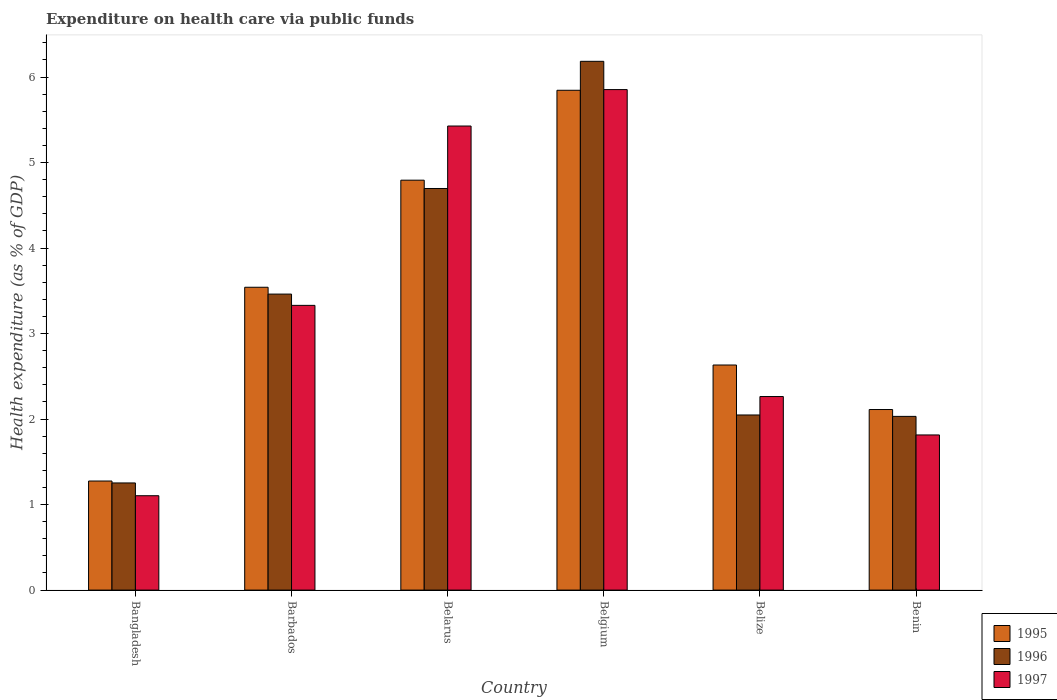How many groups of bars are there?
Keep it short and to the point. 6. How many bars are there on the 3rd tick from the right?
Give a very brief answer. 3. What is the label of the 2nd group of bars from the left?
Offer a very short reply. Barbados. What is the expenditure made on health care in 1995 in Bangladesh?
Give a very brief answer. 1.28. Across all countries, what is the maximum expenditure made on health care in 1996?
Ensure brevity in your answer.  6.18. Across all countries, what is the minimum expenditure made on health care in 1996?
Provide a short and direct response. 1.25. What is the total expenditure made on health care in 1997 in the graph?
Offer a very short reply. 19.79. What is the difference between the expenditure made on health care in 1995 in Belarus and that in Benin?
Give a very brief answer. 2.68. What is the difference between the expenditure made on health care in 1995 in Belgium and the expenditure made on health care in 1997 in Belarus?
Provide a short and direct response. 0.42. What is the average expenditure made on health care in 1996 per country?
Offer a very short reply. 3.28. What is the difference between the expenditure made on health care of/in 1995 and expenditure made on health care of/in 1996 in Belarus?
Offer a very short reply. 0.1. What is the ratio of the expenditure made on health care in 1997 in Bangladesh to that in Belarus?
Ensure brevity in your answer.  0.2. Is the difference between the expenditure made on health care in 1995 in Bangladesh and Benin greater than the difference between the expenditure made on health care in 1996 in Bangladesh and Benin?
Make the answer very short. No. What is the difference between the highest and the second highest expenditure made on health care in 1996?
Give a very brief answer. -1.23. What is the difference between the highest and the lowest expenditure made on health care in 1996?
Provide a succinct answer. 4.93. In how many countries, is the expenditure made on health care in 1995 greater than the average expenditure made on health care in 1995 taken over all countries?
Offer a terse response. 3. Is the sum of the expenditure made on health care in 1995 in Belgium and Belize greater than the maximum expenditure made on health care in 1997 across all countries?
Make the answer very short. Yes. What does the 1st bar from the left in Belarus represents?
Offer a terse response. 1995. How many bars are there?
Provide a succinct answer. 18. Are all the bars in the graph horizontal?
Offer a very short reply. No. How many countries are there in the graph?
Make the answer very short. 6. Does the graph contain grids?
Keep it short and to the point. No. Where does the legend appear in the graph?
Provide a short and direct response. Bottom right. How many legend labels are there?
Provide a short and direct response. 3. How are the legend labels stacked?
Offer a terse response. Vertical. What is the title of the graph?
Ensure brevity in your answer.  Expenditure on health care via public funds. What is the label or title of the X-axis?
Provide a short and direct response. Country. What is the label or title of the Y-axis?
Ensure brevity in your answer.  Health expenditure (as % of GDP). What is the Health expenditure (as % of GDP) of 1995 in Bangladesh?
Keep it short and to the point. 1.28. What is the Health expenditure (as % of GDP) in 1996 in Bangladesh?
Provide a short and direct response. 1.25. What is the Health expenditure (as % of GDP) in 1997 in Bangladesh?
Provide a succinct answer. 1.1. What is the Health expenditure (as % of GDP) of 1995 in Barbados?
Provide a short and direct response. 3.54. What is the Health expenditure (as % of GDP) in 1996 in Barbados?
Provide a short and direct response. 3.46. What is the Health expenditure (as % of GDP) in 1997 in Barbados?
Your answer should be compact. 3.33. What is the Health expenditure (as % of GDP) in 1995 in Belarus?
Provide a succinct answer. 4.79. What is the Health expenditure (as % of GDP) in 1996 in Belarus?
Provide a short and direct response. 4.7. What is the Health expenditure (as % of GDP) in 1997 in Belarus?
Offer a very short reply. 5.43. What is the Health expenditure (as % of GDP) in 1995 in Belgium?
Your answer should be very brief. 5.85. What is the Health expenditure (as % of GDP) in 1996 in Belgium?
Ensure brevity in your answer.  6.18. What is the Health expenditure (as % of GDP) in 1997 in Belgium?
Provide a succinct answer. 5.85. What is the Health expenditure (as % of GDP) in 1995 in Belize?
Your answer should be very brief. 2.63. What is the Health expenditure (as % of GDP) of 1996 in Belize?
Your answer should be compact. 2.05. What is the Health expenditure (as % of GDP) in 1997 in Belize?
Provide a succinct answer. 2.26. What is the Health expenditure (as % of GDP) of 1995 in Benin?
Your answer should be very brief. 2.11. What is the Health expenditure (as % of GDP) of 1996 in Benin?
Keep it short and to the point. 2.03. What is the Health expenditure (as % of GDP) in 1997 in Benin?
Your answer should be very brief. 1.81. Across all countries, what is the maximum Health expenditure (as % of GDP) of 1995?
Keep it short and to the point. 5.85. Across all countries, what is the maximum Health expenditure (as % of GDP) in 1996?
Your answer should be compact. 6.18. Across all countries, what is the maximum Health expenditure (as % of GDP) in 1997?
Offer a terse response. 5.85. Across all countries, what is the minimum Health expenditure (as % of GDP) in 1995?
Your answer should be compact. 1.28. Across all countries, what is the minimum Health expenditure (as % of GDP) of 1996?
Provide a succinct answer. 1.25. Across all countries, what is the minimum Health expenditure (as % of GDP) of 1997?
Offer a terse response. 1.1. What is the total Health expenditure (as % of GDP) of 1995 in the graph?
Offer a very short reply. 20.2. What is the total Health expenditure (as % of GDP) of 1996 in the graph?
Your response must be concise. 19.68. What is the total Health expenditure (as % of GDP) in 1997 in the graph?
Give a very brief answer. 19.79. What is the difference between the Health expenditure (as % of GDP) of 1995 in Bangladesh and that in Barbados?
Offer a terse response. -2.27. What is the difference between the Health expenditure (as % of GDP) of 1996 in Bangladesh and that in Barbados?
Make the answer very short. -2.21. What is the difference between the Health expenditure (as % of GDP) of 1997 in Bangladesh and that in Barbados?
Your response must be concise. -2.23. What is the difference between the Health expenditure (as % of GDP) of 1995 in Bangladesh and that in Belarus?
Make the answer very short. -3.52. What is the difference between the Health expenditure (as % of GDP) in 1996 in Bangladesh and that in Belarus?
Offer a terse response. -3.44. What is the difference between the Health expenditure (as % of GDP) of 1997 in Bangladesh and that in Belarus?
Offer a terse response. -4.32. What is the difference between the Health expenditure (as % of GDP) of 1995 in Bangladesh and that in Belgium?
Provide a short and direct response. -4.57. What is the difference between the Health expenditure (as % of GDP) of 1996 in Bangladesh and that in Belgium?
Your answer should be very brief. -4.93. What is the difference between the Health expenditure (as % of GDP) of 1997 in Bangladesh and that in Belgium?
Offer a very short reply. -4.75. What is the difference between the Health expenditure (as % of GDP) of 1995 in Bangladesh and that in Belize?
Offer a terse response. -1.36. What is the difference between the Health expenditure (as % of GDP) in 1996 in Bangladesh and that in Belize?
Make the answer very short. -0.79. What is the difference between the Health expenditure (as % of GDP) of 1997 in Bangladesh and that in Belize?
Offer a terse response. -1.16. What is the difference between the Health expenditure (as % of GDP) of 1995 in Bangladesh and that in Benin?
Your answer should be compact. -0.84. What is the difference between the Health expenditure (as % of GDP) of 1996 in Bangladesh and that in Benin?
Give a very brief answer. -0.78. What is the difference between the Health expenditure (as % of GDP) of 1997 in Bangladesh and that in Benin?
Ensure brevity in your answer.  -0.71. What is the difference between the Health expenditure (as % of GDP) in 1995 in Barbados and that in Belarus?
Your response must be concise. -1.25. What is the difference between the Health expenditure (as % of GDP) of 1996 in Barbados and that in Belarus?
Offer a very short reply. -1.23. What is the difference between the Health expenditure (as % of GDP) of 1997 in Barbados and that in Belarus?
Your answer should be compact. -2.1. What is the difference between the Health expenditure (as % of GDP) in 1995 in Barbados and that in Belgium?
Your answer should be very brief. -2.3. What is the difference between the Health expenditure (as % of GDP) in 1996 in Barbados and that in Belgium?
Ensure brevity in your answer.  -2.72. What is the difference between the Health expenditure (as % of GDP) in 1997 in Barbados and that in Belgium?
Provide a short and direct response. -2.52. What is the difference between the Health expenditure (as % of GDP) of 1995 in Barbados and that in Belize?
Your answer should be very brief. 0.91. What is the difference between the Health expenditure (as % of GDP) in 1996 in Barbados and that in Belize?
Your answer should be very brief. 1.41. What is the difference between the Health expenditure (as % of GDP) of 1997 in Barbados and that in Belize?
Give a very brief answer. 1.07. What is the difference between the Health expenditure (as % of GDP) in 1995 in Barbados and that in Benin?
Offer a terse response. 1.43. What is the difference between the Health expenditure (as % of GDP) of 1996 in Barbados and that in Benin?
Make the answer very short. 1.43. What is the difference between the Health expenditure (as % of GDP) in 1997 in Barbados and that in Benin?
Keep it short and to the point. 1.52. What is the difference between the Health expenditure (as % of GDP) in 1995 in Belarus and that in Belgium?
Keep it short and to the point. -1.05. What is the difference between the Health expenditure (as % of GDP) of 1996 in Belarus and that in Belgium?
Provide a short and direct response. -1.49. What is the difference between the Health expenditure (as % of GDP) in 1997 in Belarus and that in Belgium?
Offer a terse response. -0.43. What is the difference between the Health expenditure (as % of GDP) of 1995 in Belarus and that in Belize?
Provide a succinct answer. 2.16. What is the difference between the Health expenditure (as % of GDP) in 1996 in Belarus and that in Belize?
Provide a short and direct response. 2.65. What is the difference between the Health expenditure (as % of GDP) of 1997 in Belarus and that in Belize?
Offer a terse response. 3.16. What is the difference between the Health expenditure (as % of GDP) of 1995 in Belarus and that in Benin?
Your answer should be compact. 2.68. What is the difference between the Health expenditure (as % of GDP) in 1996 in Belarus and that in Benin?
Keep it short and to the point. 2.67. What is the difference between the Health expenditure (as % of GDP) in 1997 in Belarus and that in Benin?
Keep it short and to the point. 3.61. What is the difference between the Health expenditure (as % of GDP) in 1995 in Belgium and that in Belize?
Provide a succinct answer. 3.21. What is the difference between the Health expenditure (as % of GDP) in 1996 in Belgium and that in Belize?
Ensure brevity in your answer.  4.14. What is the difference between the Health expenditure (as % of GDP) in 1997 in Belgium and that in Belize?
Make the answer very short. 3.59. What is the difference between the Health expenditure (as % of GDP) in 1995 in Belgium and that in Benin?
Offer a very short reply. 3.73. What is the difference between the Health expenditure (as % of GDP) in 1996 in Belgium and that in Benin?
Keep it short and to the point. 4.15. What is the difference between the Health expenditure (as % of GDP) of 1997 in Belgium and that in Benin?
Keep it short and to the point. 4.04. What is the difference between the Health expenditure (as % of GDP) of 1995 in Belize and that in Benin?
Provide a succinct answer. 0.52. What is the difference between the Health expenditure (as % of GDP) of 1996 in Belize and that in Benin?
Give a very brief answer. 0.02. What is the difference between the Health expenditure (as % of GDP) of 1997 in Belize and that in Benin?
Give a very brief answer. 0.45. What is the difference between the Health expenditure (as % of GDP) in 1995 in Bangladesh and the Health expenditure (as % of GDP) in 1996 in Barbados?
Your answer should be compact. -2.19. What is the difference between the Health expenditure (as % of GDP) in 1995 in Bangladesh and the Health expenditure (as % of GDP) in 1997 in Barbados?
Your answer should be very brief. -2.05. What is the difference between the Health expenditure (as % of GDP) of 1996 in Bangladesh and the Health expenditure (as % of GDP) of 1997 in Barbados?
Give a very brief answer. -2.08. What is the difference between the Health expenditure (as % of GDP) of 1995 in Bangladesh and the Health expenditure (as % of GDP) of 1996 in Belarus?
Ensure brevity in your answer.  -3.42. What is the difference between the Health expenditure (as % of GDP) in 1995 in Bangladesh and the Health expenditure (as % of GDP) in 1997 in Belarus?
Offer a terse response. -4.15. What is the difference between the Health expenditure (as % of GDP) of 1996 in Bangladesh and the Health expenditure (as % of GDP) of 1997 in Belarus?
Provide a short and direct response. -4.17. What is the difference between the Health expenditure (as % of GDP) of 1995 in Bangladesh and the Health expenditure (as % of GDP) of 1996 in Belgium?
Offer a very short reply. -4.91. What is the difference between the Health expenditure (as % of GDP) of 1995 in Bangladesh and the Health expenditure (as % of GDP) of 1997 in Belgium?
Give a very brief answer. -4.58. What is the difference between the Health expenditure (as % of GDP) of 1996 in Bangladesh and the Health expenditure (as % of GDP) of 1997 in Belgium?
Your answer should be compact. -4.6. What is the difference between the Health expenditure (as % of GDP) of 1995 in Bangladesh and the Health expenditure (as % of GDP) of 1996 in Belize?
Keep it short and to the point. -0.77. What is the difference between the Health expenditure (as % of GDP) in 1995 in Bangladesh and the Health expenditure (as % of GDP) in 1997 in Belize?
Provide a succinct answer. -0.99. What is the difference between the Health expenditure (as % of GDP) of 1996 in Bangladesh and the Health expenditure (as % of GDP) of 1997 in Belize?
Keep it short and to the point. -1.01. What is the difference between the Health expenditure (as % of GDP) in 1995 in Bangladesh and the Health expenditure (as % of GDP) in 1996 in Benin?
Offer a very short reply. -0.76. What is the difference between the Health expenditure (as % of GDP) in 1995 in Bangladesh and the Health expenditure (as % of GDP) in 1997 in Benin?
Your answer should be compact. -0.54. What is the difference between the Health expenditure (as % of GDP) in 1996 in Bangladesh and the Health expenditure (as % of GDP) in 1997 in Benin?
Offer a very short reply. -0.56. What is the difference between the Health expenditure (as % of GDP) of 1995 in Barbados and the Health expenditure (as % of GDP) of 1996 in Belarus?
Your answer should be very brief. -1.15. What is the difference between the Health expenditure (as % of GDP) in 1995 in Barbados and the Health expenditure (as % of GDP) in 1997 in Belarus?
Provide a short and direct response. -1.89. What is the difference between the Health expenditure (as % of GDP) in 1996 in Barbados and the Health expenditure (as % of GDP) in 1997 in Belarus?
Offer a terse response. -1.97. What is the difference between the Health expenditure (as % of GDP) in 1995 in Barbados and the Health expenditure (as % of GDP) in 1996 in Belgium?
Give a very brief answer. -2.64. What is the difference between the Health expenditure (as % of GDP) in 1995 in Barbados and the Health expenditure (as % of GDP) in 1997 in Belgium?
Provide a short and direct response. -2.31. What is the difference between the Health expenditure (as % of GDP) in 1996 in Barbados and the Health expenditure (as % of GDP) in 1997 in Belgium?
Keep it short and to the point. -2.39. What is the difference between the Health expenditure (as % of GDP) in 1995 in Barbados and the Health expenditure (as % of GDP) in 1996 in Belize?
Your response must be concise. 1.49. What is the difference between the Health expenditure (as % of GDP) of 1995 in Barbados and the Health expenditure (as % of GDP) of 1997 in Belize?
Provide a short and direct response. 1.28. What is the difference between the Health expenditure (as % of GDP) in 1996 in Barbados and the Health expenditure (as % of GDP) in 1997 in Belize?
Provide a short and direct response. 1.2. What is the difference between the Health expenditure (as % of GDP) in 1995 in Barbados and the Health expenditure (as % of GDP) in 1996 in Benin?
Keep it short and to the point. 1.51. What is the difference between the Health expenditure (as % of GDP) in 1995 in Barbados and the Health expenditure (as % of GDP) in 1997 in Benin?
Offer a very short reply. 1.73. What is the difference between the Health expenditure (as % of GDP) in 1996 in Barbados and the Health expenditure (as % of GDP) in 1997 in Benin?
Your answer should be compact. 1.65. What is the difference between the Health expenditure (as % of GDP) in 1995 in Belarus and the Health expenditure (as % of GDP) in 1996 in Belgium?
Provide a short and direct response. -1.39. What is the difference between the Health expenditure (as % of GDP) in 1995 in Belarus and the Health expenditure (as % of GDP) in 1997 in Belgium?
Your answer should be very brief. -1.06. What is the difference between the Health expenditure (as % of GDP) of 1996 in Belarus and the Health expenditure (as % of GDP) of 1997 in Belgium?
Ensure brevity in your answer.  -1.16. What is the difference between the Health expenditure (as % of GDP) in 1995 in Belarus and the Health expenditure (as % of GDP) in 1996 in Belize?
Provide a succinct answer. 2.75. What is the difference between the Health expenditure (as % of GDP) of 1995 in Belarus and the Health expenditure (as % of GDP) of 1997 in Belize?
Offer a very short reply. 2.53. What is the difference between the Health expenditure (as % of GDP) in 1996 in Belarus and the Health expenditure (as % of GDP) in 1997 in Belize?
Your answer should be very brief. 2.43. What is the difference between the Health expenditure (as % of GDP) of 1995 in Belarus and the Health expenditure (as % of GDP) of 1996 in Benin?
Provide a short and direct response. 2.76. What is the difference between the Health expenditure (as % of GDP) in 1995 in Belarus and the Health expenditure (as % of GDP) in 1997 in Benin?
Provide a succinct answer. 2.98. What is the difference between the Health expenditure (as % of GDP) in 1996 in Belarus and the Health expenditure (as % of GDP) in 1997 in Benin?
Provide a short and direct response. 2.88. What is the difference between the Health expenditure (as % of GDP) in 1995 in Belgium and the Health expenditure (as % of GDP) in 1996 in Belize?
Give a very brief answer. 3.8. What is the difference between the Health expenditure (as % of GDP) of 1995 in Belgium and the Health expenditure (as % of GDP) of 1997 in Belize?
Offer a very short reply. 3.58. What is the difference between the Health expenditure (as % of GDP) of 1996 in Belgium and the Health expenditure (as % of GDP) of 1997 in Belize?
Your answer should be compact. 3.92. What is the difference between the Health expenditure (as % of GDP) of 1995 in Belgium and the Health expenditure (as % of GDP) of 1996 in Benin?
Give a very brief answer. 3.81. What is the difference between the Health expenditure (as % of GDP) in 1995 in Belgium and the Health expenditure (as % of GDP) in 1997 in Benin?
Offer a terse response. 4.03. What is the difference between the Health expenditure (as % of GDP) of 1996 in Belgium and the Health expenditure (as % of GDP) of 1997 in Benin?
Your answer should be very brief. 4.37. What is the difference between the Health expenditure (as % of GDP) of 1995 in Belize and the Health expenditure (as % of GDP) of 1996 in Benin?
Ensure brevity in your answer.  0.6. What is the difference between the Health expenditure (as % of GDP) in 1995 in Belize and the Health expenditure (as % of GDP) in 1997 in Benin?
Provide a short and direct response. 0.82. What is the difference between the Health expenditure (as % of GDP) of 1996 in Belize and the Health expenditure (as % of GDP) of 1997 in Benin?
Offer a terse response. 0.23. What is the average Health expenditure (as % of GDP) of 1995 per country?
Your answer should be compact. 3.37. What is the average Health expenditure (as % of GDP) in 1996 per country?
Give a very brief answer. 3.28. What is the average Health expenditure (as % of GDP) of 1997 per country?
Give a very brief answer. 3.3. What is the difference between the Health expenditure (as % of GDP) in 1995 and Health expenditure (as % of GDP) in 1996 in Bangladesh?
Your answer should be very brief. 0.02. What is the difference between the Health expenditure (as % of GDP) of 1995 and Health expenditure (as % of GDP) of 1997 in Bangladesh?
Offer a very short reply. 0.17. What is the difference between the Health expenditure (as % of GDP) of 1996 and Health expenditure (as % of GDP) of 1997 in Bangladesh?
Give a very brief answer. 0.15. What is the difference between the Health expenditure (as % of GDP) in 1995 and Health expenditure (as % of GDP) in 1997 in Barbados?
Provide a succinct answer. 0.21. What is the difference between the Health expenditure (as % of GDP) of 1996 and Health expenditure (as % of GDP) of 1997 in Barbados?
Provide a succinct answer. 0.13. What is the difference between the Health expenditure (as % of GDP) in 1995 and Health expenditure (as % of GDP) in 1996 in Belarus?
Make the answer very short. 0.1. What is the difference between the Health expenditure (as % of GDP) in 1995 and Health expenditure (as % of GDP) in 1997 in Belarus?
Keep it short and to the point. -0.63. What is the difference between the Health expenditure (as % of GDP) in 1996 and Health expenditure (as % of GDP) in 1997 in Belarus?
Give a very brief answer. -0.73. What is the difference between the Health expenditure (as % of GDP) of 1995 and Health expenditure (as % of GDP) of 1996 in Belgium?
Your answer should be very brief. -0.34. What is the difference between the Health expenditure (as % of GDP) in 1995 and Health expenditure (as % of GDP) in 1997 in Belgium?
Your response must be concise. -0.01. What is the difference between the Health expenditure (as % of GDP) in 1996 and Health expenditure (as % of GDP) in 1997 in Belgium?
Provide a short and direct response. 0.33. What is the difference between the Health expenditure (as % of GDP) in 1995 and Health expenditure (as % of GDP) in 1996 in Belize?
Give a very brief answer. 0.58. What is the difference between the Health expenditure (as % of GDP) of 1995 and Health expenditure (as % of GDP) of 1997 in Belize?
Your answer should be compact. 0.37. What is the difference between the Health expenditure (as % of GDP) of 1996 and Health expenditure (as % of GDP) of 1997 in Belize?
Keep it short and to the point. -0.22. What is the difference between the Health expenditure (as % of GDP) in 1995 and Health expenditure (as % of GDP) in 1996 in Benin?
Keep it short and to the point. 0.08. What is the difference between the Health expenditure (as % of GDP) of 1995 and Health expenditure (as % of GDP) of 1997 in Benin?
Your answer should be compact. 0.3. What is the difference between the Health expenditure (as % of GDP) in 1996 and Health expenditure (as % of GDP) in 1997 in Benin?
Offer a terse response. 0.22. What is the ratio of the Health expenditure (as % of GDP) of 1995 in Bangladesh to that in Barbados?
Provide a succinct answer. 0.36. What is the ratio of the Health expenditure (as % of GDP) in 1996 in Bangladesh to that in Barbados?
Your answer should be very brief. 0.36. What is the ratio of the Health expenditure (as % of GDP) in 1997 in Bangladesh to that in Barbados?
Make the answer very short. 0.33. What is the ratio of the Health expenditure (as % of GDP) in 1995 in Bangladesh to that in Belarus?
Offer a terse response. 0.27. What is the ratio of the Health expenditure (as % of GDP) in 1996 in Bangladesh to that in Belarus?
Your answer should be compact. 0.27. What is the ratio of the Health expenditure (as % of GDP) in 1997 in Bangladesh to that in Belarus?
Keep it short and to the point. 0.2. What is the ratio of the Health expenditure (as % of GDP) in 1995 in Bangladesh to that in Belgium?
Keep it short and to the point. 0.22. What is the ratio of the Health expenditure (as % of GDP) of 1996 in Bangladesh to that in Belgium?
Provide a succinct answer. 0.2. What is the ratio of the Health expenditure (as % of GDP) in 1997 in Bangladesh to that in Belgium?
Make the answer very short. 0.19. What is the ratio of the Health expenditure (as % of GDP) in 1995 in Bangladesh to that in Belize?
Offer a very short reply. 0.48. What is the ratio of the Health expenditure (as % of GDP) of 1996 in Bangladesh to that in Belize?
Keep it short and to the point. 0.61. What is the ratio of the Health expenditure (as % of GDP) in 1997 in Bangladesh to that in Belize?
Provide a short and direct response. 0.49. What is the ratio of the Health expenditure (as % of GDP) in 1995 in Bangladesh to that in Benin?
Offer a terse response. 0.6. What is the ratio of the Health expenditure (as % of GDP) of 1996 in Bangladesh to that in Benin?
Your answer should be compact. 0.62. What is the ratio of the Health expenditure (as % of GDP) of 1997 in Bangladesh to that in Benin?
Keep it short and to the point. 0.61. What is the ratio of the Health expenditure (as % of GDP) of 1995 in Barbados to that in Belarus?
Ensure brevity in your answer.  0.74. What is the ratio of the Health expenditure (as % of GDP) of 1996 in Barbados to that in Belarus?
Ensure brevity in your answer.  0.74. What is the ratio of the Health expenditure (as % of GDP) in 1997 in Barbados to that in Belarus?
Provide a succinct answer. 0.61. What is the ratio of the Health expenditure (as % of GDP) in 1995 in Barbados to that in Belgium?
Keep it short and to the point. 0.61. What is the ratio of the Health expenditure (as % of GDP) in 1996 in Barbados to that in Belgium?
Provide a succinct answer. 0.56. What is the ratio of the Health expenditure (as % of GDP) of 1997 in Barbados to that in Belgium?
Your answer should be very brief. 0.57. What is the ratio of the Health expenditure (as % of GDP) of 1995 in Barbados to that in Belize?
Provide a short and direct response. 1.35. What is the ratio of the Health expenditure (as % of GDP) in 1996 in Barbados to that in Belize?
Keep it short and to the point. 1.69. What is the ratio of the Health expenditure (as % of GDP) of 1997 in Barbados to that in Belize?
Your answer should be very brief. 1.47. What is the ratio of the Health expenditure (as % of GDP) in 1995 in Barbados to that in Benin?
Your response must be concise. 1.68. What is the ratio of the Health expenditure (as % of GDP) of 1996 in Barbados to that in Benin?
Make the answer very short. 1.7. What is the ratio of the Health expenditure (as % of GDP) in 1997 in Barbados to that in Benin?
Provide a short and direct response. 1.84. What is the ratio of the Health expenditure (as % of GDP) of 1995 in Belarus to that in Belgium?
Give a very brief answer. 0.82. What is the ratio of the Health expenditure (as % of GDP) in 1996 in Belarus to that in Belgium?
Your response must be concise. 0.76. What is the ratio of the Health expenditure (as % of GDP) of 1997 in Belarus to that in Belgium?
Make the answer very short. 0.93. What is the ratio of the Health expenditure (as % of GDP) of 1995 in Belarus to that in Belize?
Provide a succinct answer. 1.82. What is the ratio of the Health expenditure (as % of GDP) in 1996 in Belarus to that in Belize?
Your response must be concise. 2.29. What is the ratio of the Health expenditure (as % of GDP) in 1997 in Belarus to that in Belize?
Provide a short and direct response. 2.4. What is the ratio of the Health expenditure (as % of GDP) of 1995 in Belarus to that in Benin?
Keep it short and to the point. 2.27. What is the ratio of the Health expenditure (as % of GDP) of 1996 in Belarus to that in Benin?
Your response must be concise. 2.31. What is the ratio of the Health expenditure (as % of GDP) of 1997 in Belarus to that in Benin?
Keep it short and to the point. 2.99. What is the ratio of the Health expenditure (as % of GDP) in 1995 in Belgium to that in Belize?
Give a very brief answer. 2.22. What is the ratio of the Health expenditure (as % of GDP) in 1996 in Belgium to that in Belize?
Provide a short and direct response. 3.02. What is the ratio of the Health expenditure (as % of GDP) in 1997 in Belgium to that in Belize?
Provide a succinct answer. 2.59. What is the ratio of the Health expenditure (as % of GDP) in 1995 in Belgium to that in Benin?
Keep it short and to the point. 2.77. What is the ratio of the Health expenditure (as % of GDP) of 1996 in Belgium to that in Benin?
Offer a very short reply. 3.04. What is the ratio of the Health expenditure (as % of GDP) in 1997 in Belgium to that in Benin?
Make the answer very short. 3.23. What is the ratio of the Health expenditure (as % of GDP) in 1995 in Belize to that in Benin?
Offer a very short reply. 1.25. What is the ratio of the Health expenditure (as % of GDP) of 1997 in Belize to that in Benin?
Provide a succinct answer. 1.25. What is the difference between the highest and the second highest Health expenditure (as % of GDP) in 1995?
Make the answer very short. 1.05. What is the difference between the highest and the second highest Health expenditure (as % of GDP) in 1996?
Offer a terse response. 1.49. What is the difference between the highest and the second highest Health expenditure (as % of GDP) of 1997?
Your response must be concise. 0.43. What is the difference between the highest and the lowest Health expenditure (as % of GDP) of 1995?
Offer a terse response. 4.57. What is the difference between the highest and the lowest Health expenditure (as % of GDP) in 1996?
Your answer should be compact. 4.93. What is the difference between the highest and the lowest Health expenditure (as % of GDP) of 1997?
Provide a short and direct response. 4.75. 